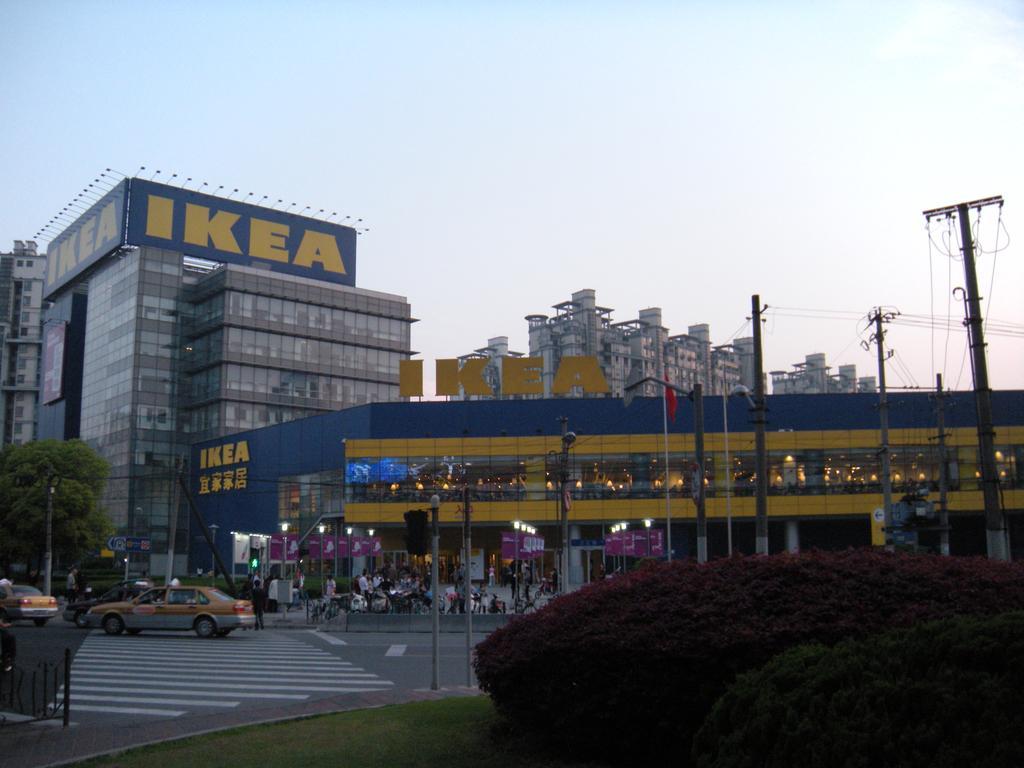How would you summarize this image in a sentence or two? In this image we can see the glass building. And we can see the windows. And we can see the street lights and electric poles. And we can see the flag. And we can see the vehicles on the road. And we can see the plants and trees. And we can see the clouds in the sky. 